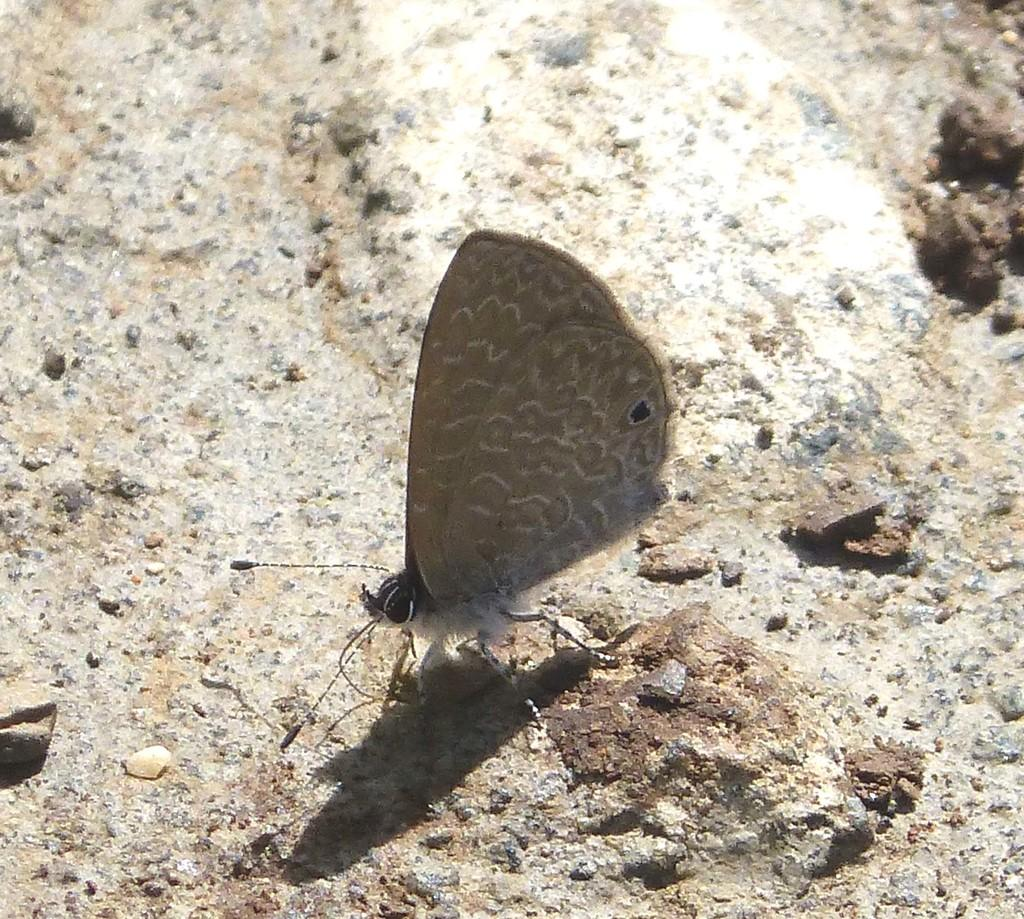What is the main subject in the center of the image? There is a butterfly in the center of the image. What can be seen at the bottom of the image? There is a rock at the bottom of the image. What type of ear can be seen on the butterfly in the image? Butterflies do not have ears; they have antennae for sensing their environment. 